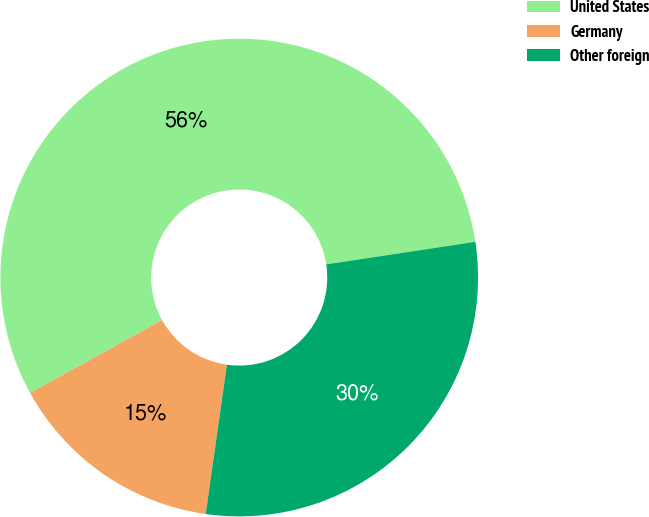Convert chart. <chart><loc_0><loc_0><loc_500><loc_500><pie_chart><fcel>United States<fcel>Germany<fcel>Other foreign<nl><fcel>55.63%<fcel>14.74%<fcel>29.63%<nl></chart> 